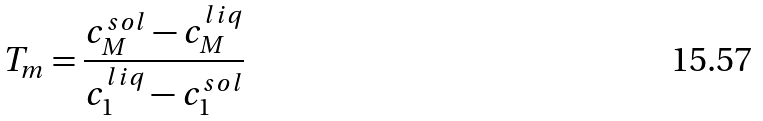<formula> <loc_0><loc_0><loc_500><loc_500>T _ { m } = \frac { c _ { M } ^ { s o l } - c _ { M } ^ { l i q } } { c _ { 1 } ^ { l i q } - c _ { 1 } ^ { s o l } }</formula> 